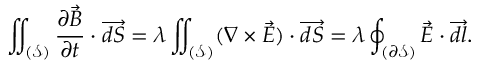<formula> <loc_0><loc_0><loc_500><loc_500>\iint _ { ( \mathcal { S } ) } \frac { \partial \ V e c { B } } { \partial t } \cdot \overrightarrow { d S } = \lambda \iint _ { ( \mathcal { S } ) } ( \nabla \times \vec { E } ) \cdot \overrightarrow { d S } = \lambda \oint _ { ( \partial \mathcal { S } ) } \ V e c { E } \cdot \overrightarrow { d l } .</formula> 